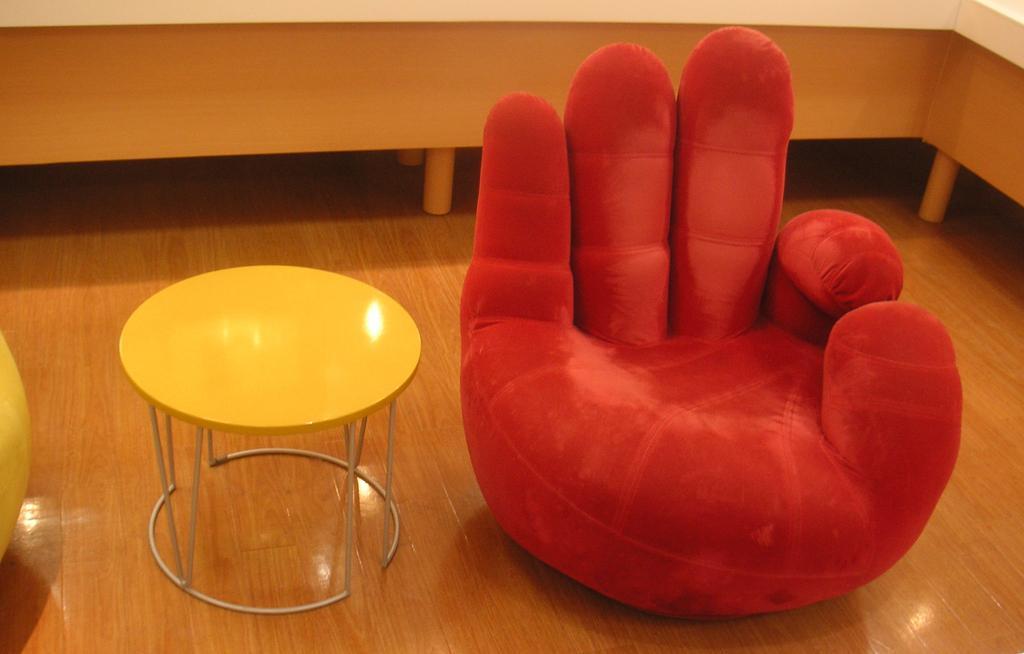How would you summarize this image in a sentence or two? Here on the floor we can see a table and a chair which is designed very nicely in red colour. 